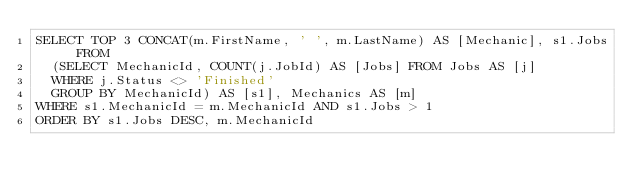Convert code to text. <code><loc_0><loc_0><loc_500><loc_500><_SQL_>SELECT TOP 3 CONCAT(m.FirstName, ' ', m.LastName) AS [Mechanic], s1.Jobs FROM
	(SELECT MechanicId, COUNT(j.JobId) AS [Jobs] FROM Jobs AS [j]
	WHERE j.Status <> 'Finished'
	GROUP BY MechanicId) AS [s1], Mechanics AS [m]
WHERE s1.MechanicId = m.MechanicId AND s1.Jobs > 1
ORDER BY s1.Jobs DESC, m.MechanicId</code> 